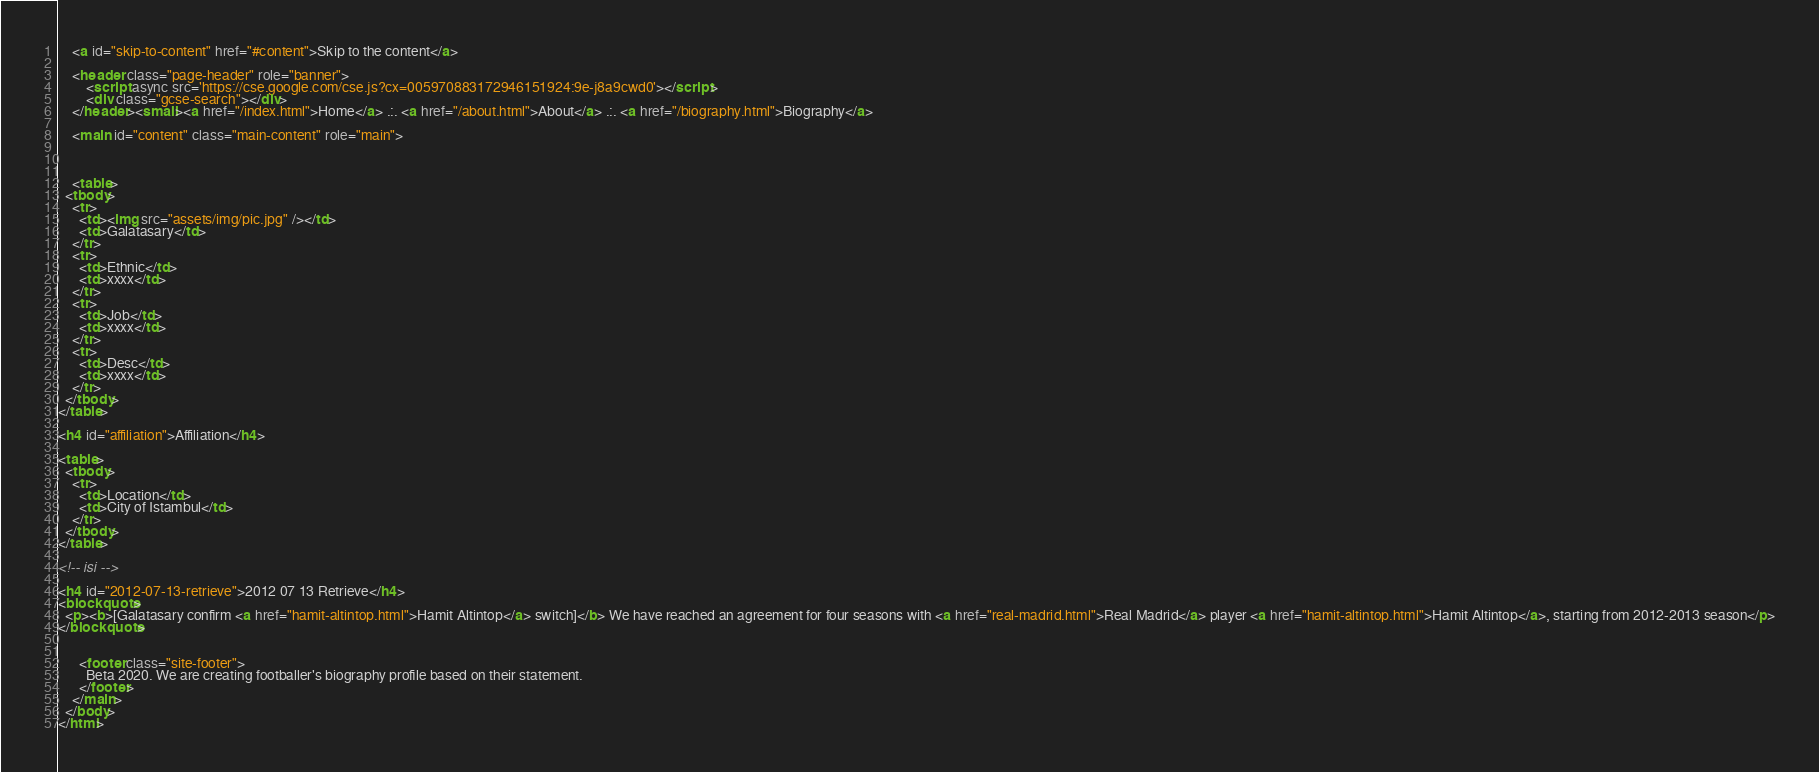<code> <loc_0><loc_0><loc_500><loc_500><_HTML_>    <a id="skip-to-content" href="#content">Skip to the content</a>

    <header class="page-header" role="banner">
	    <script async src='https://cse.google.com/cse.js?cx=005970883172946151924:9e-j8a9cwd0'></script>
	    <div class="gcse-search"></div>      
    </header><small><a href="/index.html">Home</a> .:. <a href="/about.html">About</a> .:. <a href="/biography.html">Biography</a>
	    
    <main id="content" class="main-content" role="main">
	
    
    
    <table>
  <tbody>
    <tr>
      <td><img src="assets/img/pic.jpg" /></td>
      <td>Galatasary</td>
    </tr>
    <tr>
      <td>Ethnic</td>
      <td>xxxx</td>
    </tr>
    <tr>
      <td>Job</td>
      <td>xxxx</td>
    </tr>
    <tr>
      <td>Desc</td>
      <td>xxxx</td>
    </tr>
  </tbody>
</table>

<h4 id="affiliation">Affiliation</h4>

<table>
  <tbody>
    <tr>
      <td>Location</td>
      <td>City of Istambul</td>
    </tr>
  </tbody>
</table>

<!-- isi -->

<h4 id="2012-07-13-retrieve">2012 07 13 Retrieve</h4>
<blockquote>
  <p><b>[Galatasary confirm <a href="hamit-altintop.html">Hamit Altintop</a> switch]</b> We have reached an agreement for four seasons with <a href="real-madrid.html">Real Madrid</a> player <a href="hamit-altintop.html">Hamit Altintop</a>, starting from 2012-2013 season</p>
</blockquote>

    
      <footer class="site-footer">	  
        Beta 2020. We are creating footballer's biography profile based on their statement.
      </footer>
    </main>
  </body>
</html>
</code> 